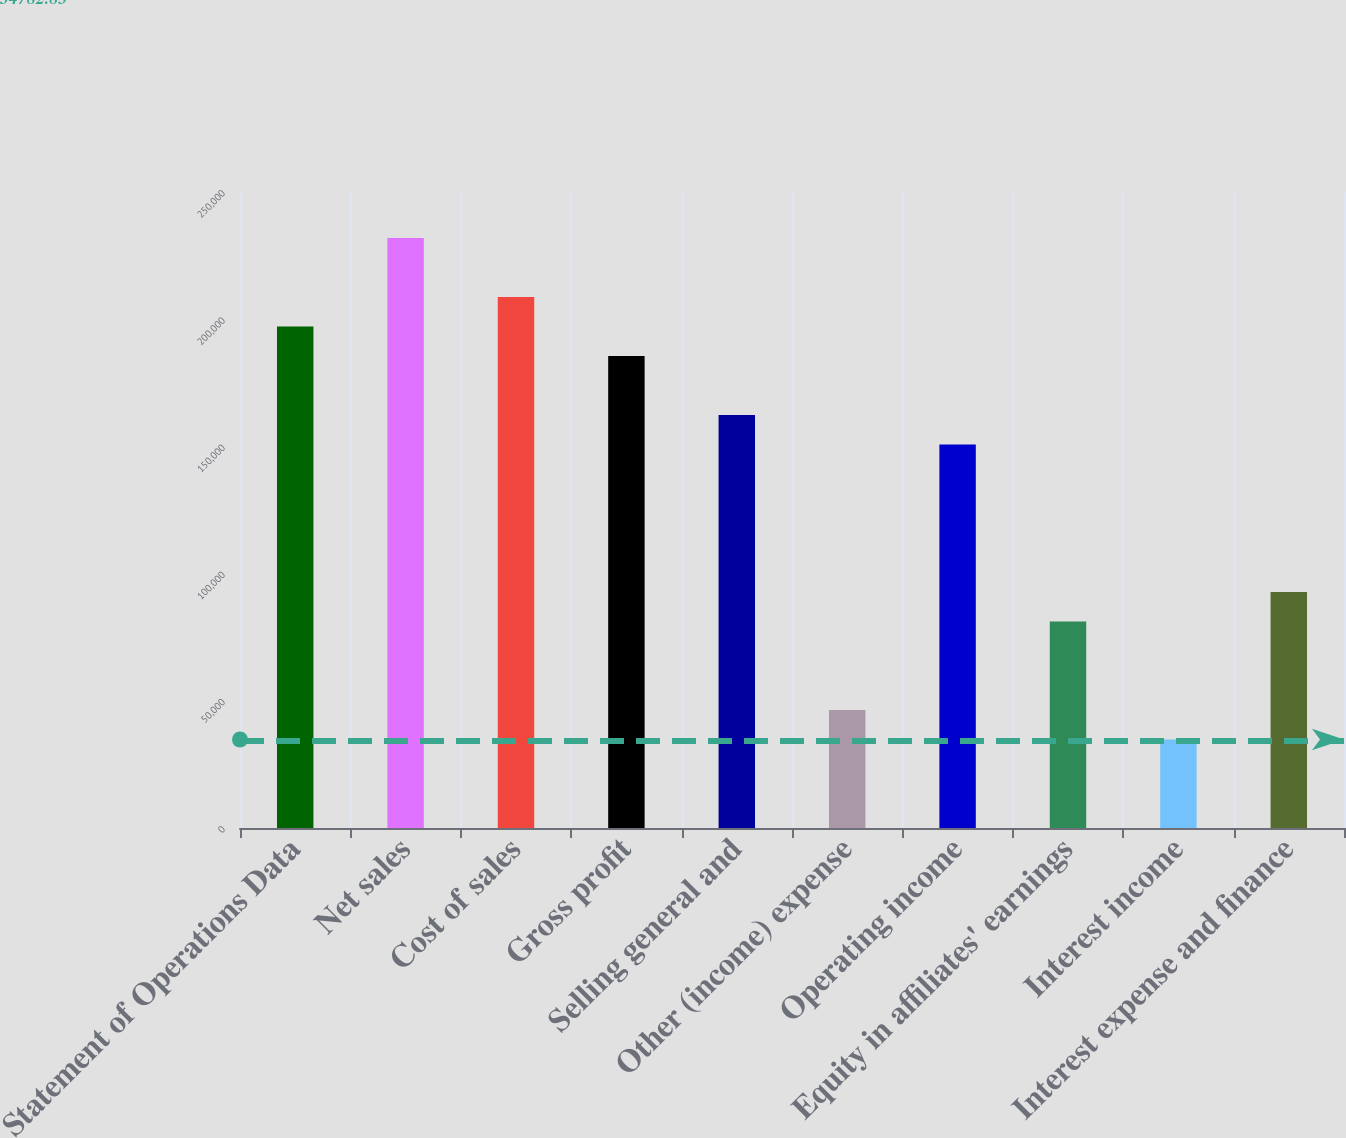Convert chart. <chart><loc_0><loc_0><loc_500><loc_500><bar_chart><fcel>Statement of Operations Data<fcel>Net sales<fcel>Cost of sales<fcel>Gross profit<fcel>Selling general and<fcel>Other (income) expense<fcel>Operating income<fcel>Equity in affiliates' earnings<fcel>Interest income<fcel>Interest expense and finance<nl><fcel>197101<fcel>231884<fcel>208695<fcel>185507<fcel>162319<fcel>46377<fcel>150725<fcel>81159.5<fcel>34782.8<fcel>92753.7<nl></chart> 